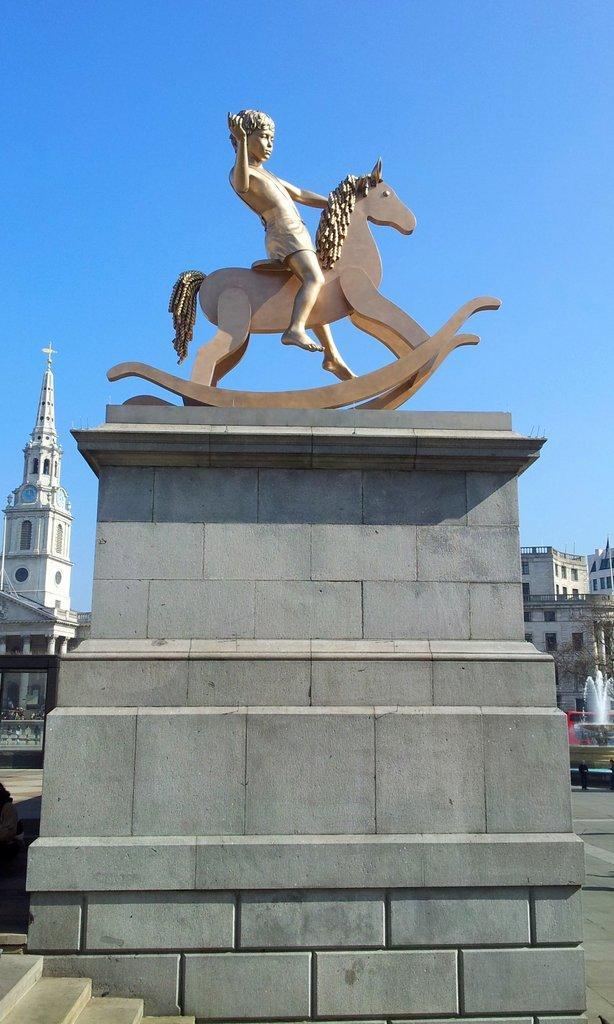Could you give a brief overview of what you see in this image? In this image we can see a statue of a boy sat on the horse and this statue placed on the rock structure, behind this there are buildings and fountain. In the background there is a sky. 